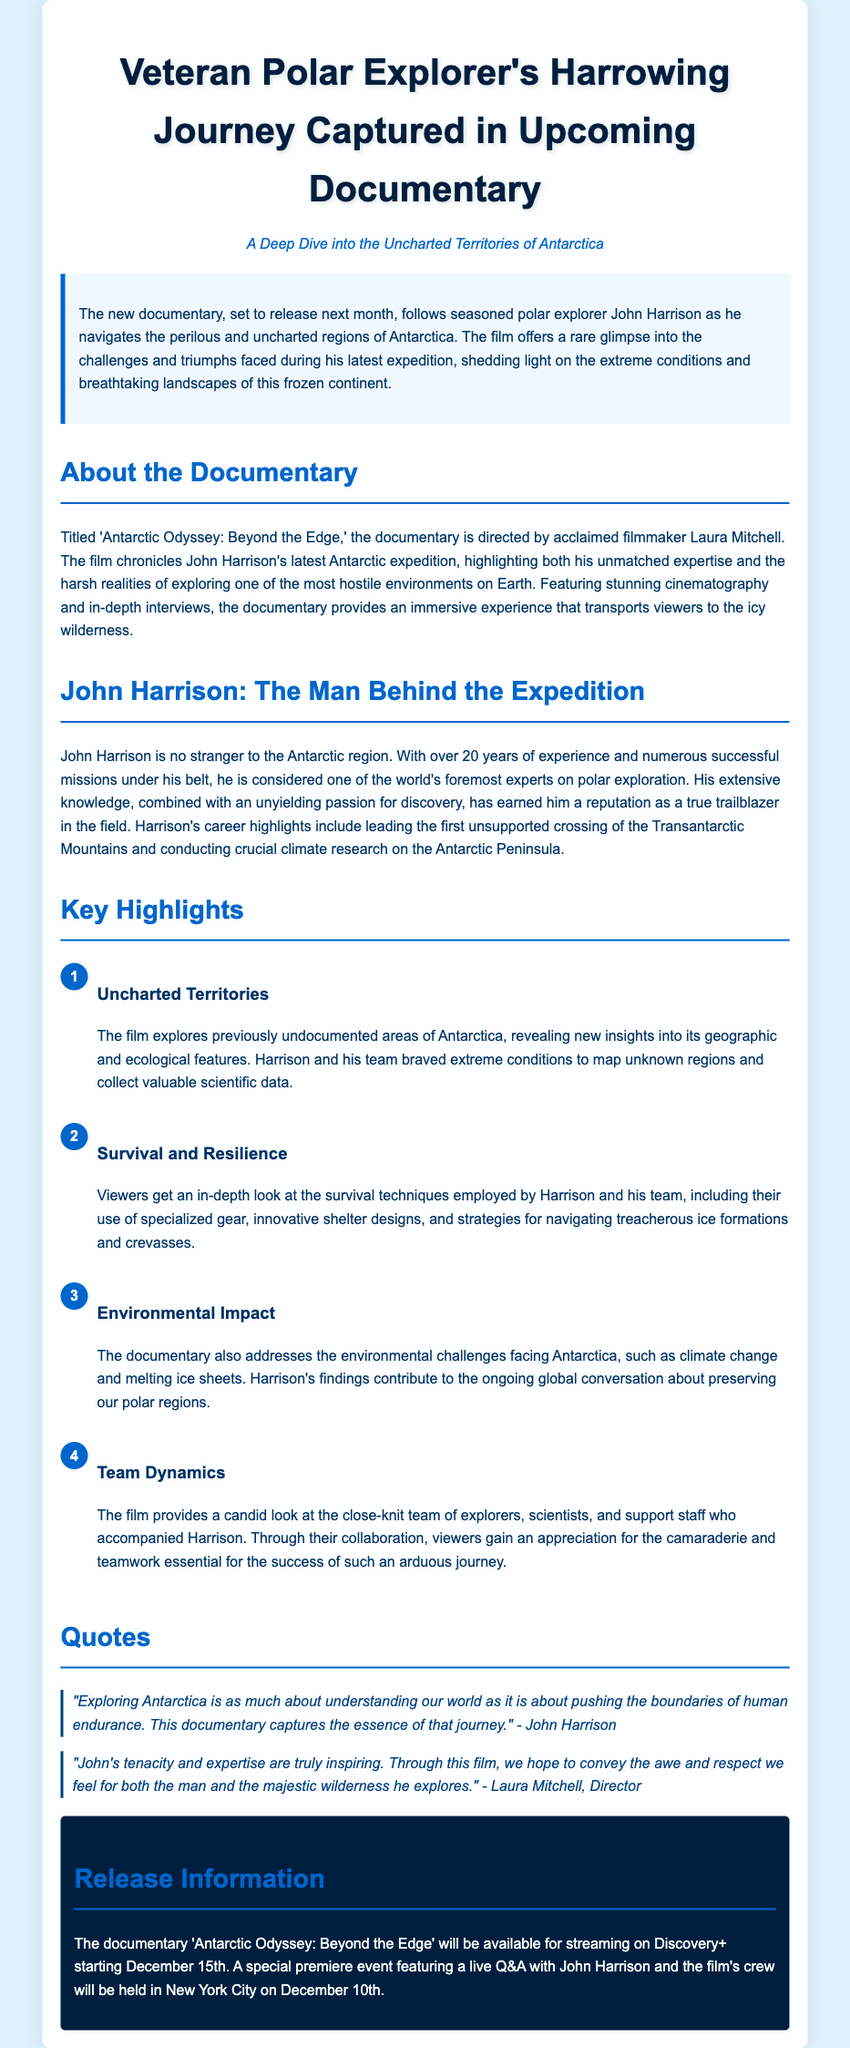What is the title of the documentary? The title of the documentary is mentioned in the section about the documentary.
Answer: Antarctic Odyssey: Beyond the Edge Who is the director of the documentary? The director's name is provided in the information about the documentary.
Answer: Laura Mitchell When will the documentary be available for streaming? The streaming date is given in the release information section.
Answer: December 15th What significant achievement is John Harrison known for? The highlight of Harrison's career is mentioned in the section about him.
Answer: First unsupported crossing of the Transantarctic Mountains What are the three main topics covered in the documentary? The key highlights section lists the main topics addressed in the documentary.
Answer: Uncharted Territories, Survival and Resilience, Environmental Impact What is the purpose of the live Q&A event? The purpose of the event is implied in the context of promoting the documentary and engaging with the audience.
Answer: Live interaction between the audience and the crew How long has John Harrison been exploring Antarctica? The document states Harrison's experience in the context of his background.
Answer: Over 20 years What is the main focus of the documentary? The summary describes the overall theme and focus of the film.
Answer: Challenges and triumphs faced during his latest expedition 